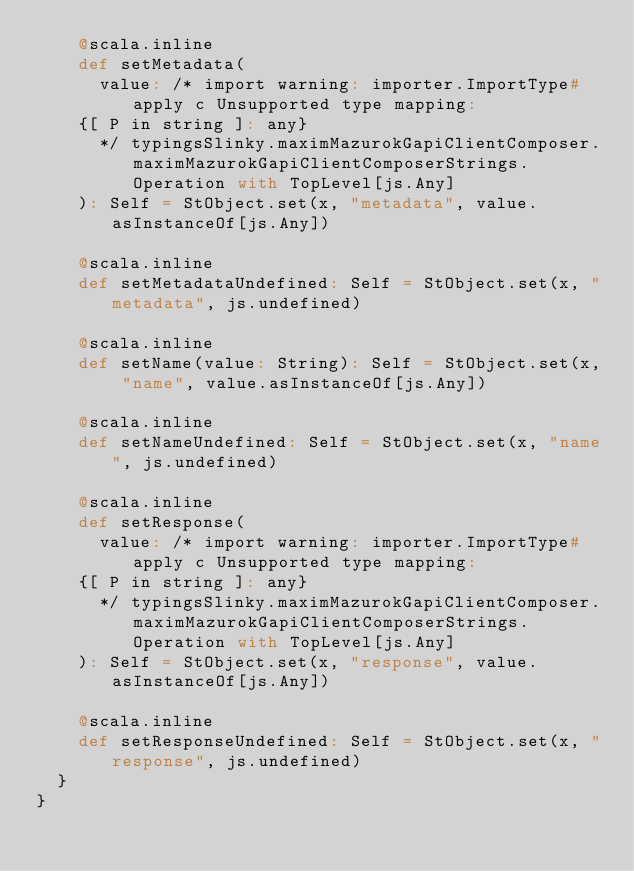Convert code to text. <code><loc_0><loc_0><loc_500><loc_500><_Scala_>    @scala.inline
    def setMetadata(
      value: /* import warning: importer.ImportType#apply c Unsupported type mapping: 
    {[ P in string ]: any}
      */ typingsSlinky.maximMazurokGapiClientComposer.maximMazurokGapiClientComposerStrings.Operation with TopLevel[js.Any]
    ): Self = StObject.set(x, "metadata", value.asInstanceOf[js.Any])
    
    @scala.inline
    def setMetadataUndefined: Self = StObject.set(x, "metadata", js.undefined)
    
    @scala.inline
    def setName(value: String): Self = StObject.set(x, "name", value.asInstanceOf[js.Any])
    
    @scala.inline
    def setNameUndefined: Self = StObject.set(x, "name", js.undefined)
    
    @scala.inline
    def setResponse(
      value: /* import warning: importer.ImportType#apply c Unsupported type mapping: 
    {[ P in string ]: any}
      */ typingsSlinky.maximMazurokGapiClientComposer.maximMazurokGapiClientComposerStrings.Operation with TopLevel[js.Any]
    ): Self = StObject.set(x, "response", value.asInstanceOf[js.Any])
    
    @scala.inline
    def setResponseUndefined: Self = StObject.set(x, "response", js.undefined)
  }
}
</code> 